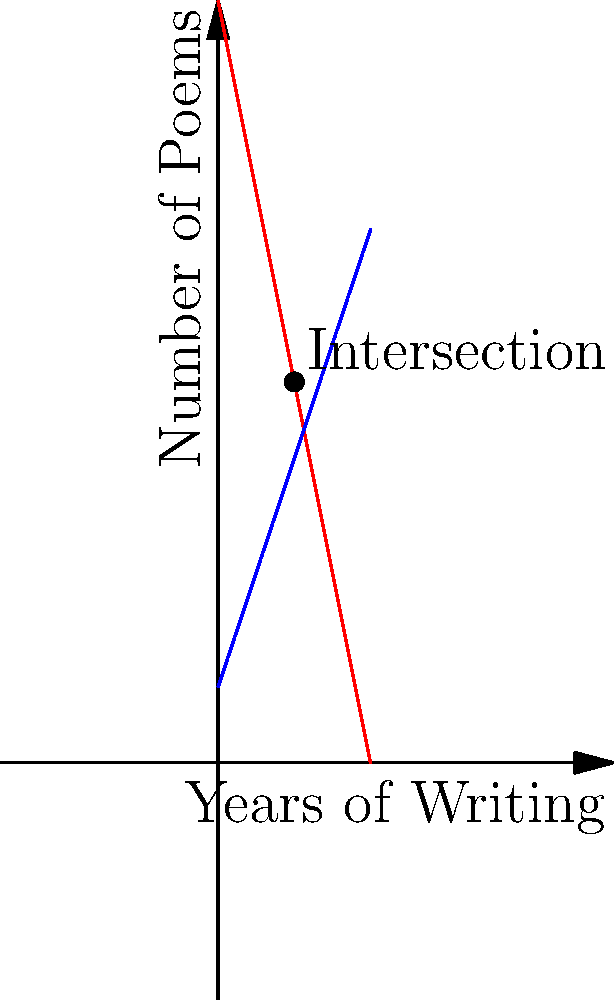In the graph above, the red line represents failed poetry submissions, while the blue line represents successful publications over years of writing. At what point do these lines intersect, and what ironic realization might our sarcastic poet draw from this confluence of poetic fortune? To find the intersection point, we need to solve the equations for both lines:

1. Failed Submissions (red line): $y = 50 - 5x$
2. Successful Publications (blue line): $y = 5 + 3x$

At the intersection point, both equations are equal:

$50 - 5x = 5 + 3x$

Solving for $x$:
$45 = 8x$
$x = 5.625$

Rounding to the nearest whole number (as we're dealing with years), $x = 6$ years.

To find the $y$ value, we can plug this back into either equation:
$y = 50 - 5(6) = 20$

So, the lines intersect at approximately (6, 20).

The ironic realization: After 6 years of writing, the poet's number of failed submissions (20) equals their number of successful publications (20). This suggests that failure and success have achieved a perfect balance, perhaps indicating that the poet has finally "made it" – but at the cost of an equal number of rejections.
Answer: (6, 20); Equal failures and successes after 6 years 